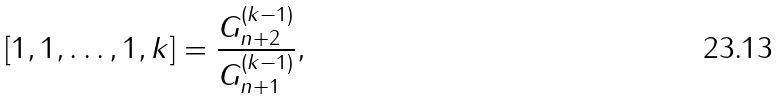<formula> <loc_0><loc_0><loc_500><loc_500>[ 1 , 1 , \dots , 1 , k ] = \frac { G _ { n + 2 } ^ { ( k - 1 ) } } { G _ { n + 1 } ^ { ( k - 1 ) } } ,</formula> 